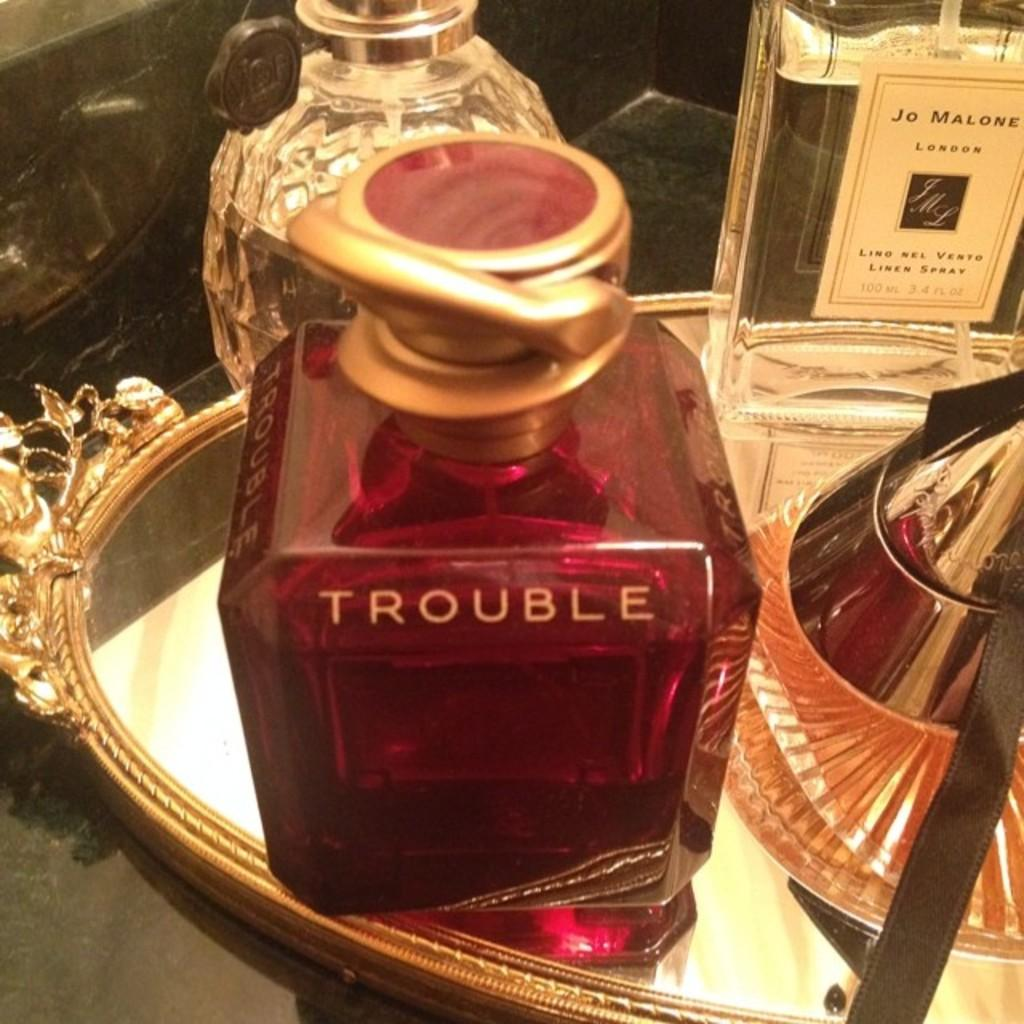<image>
Give a short and clear explanation of the subsequent image. Bottle of TROUBLE on top of a golden plte. 